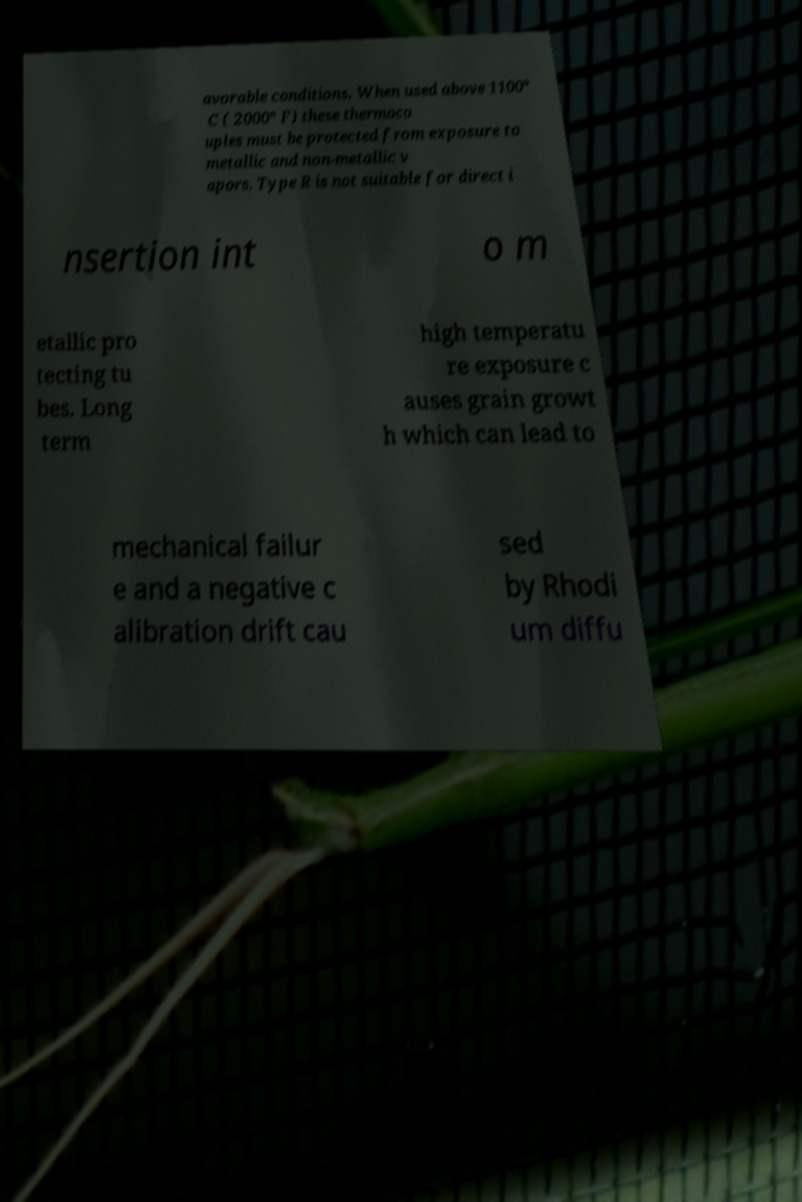Can you read and provide the text displayed in the image?This photo seems to have some interesting text. Can you extract and type it out for me? avorable conditions. When used above 1100° C ( 2000° F) these thermoco uples must be protected from exposure to metallic and non-metallic v apors. Type R is not suitable for direct i nsertion int o m etallic pro tecting tu bes. Long term high temperatu re exposure c auses grain growt h which can lead to mechanical failur e and a negative c alibration drift cau sed by Rhodi um diffu 